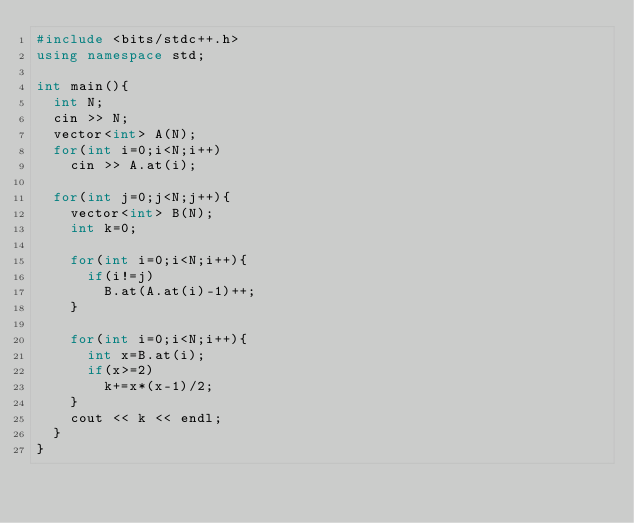<code> <loc_0><loc_0><loc_500><loc_500><_C++_>#include <bits/stdc++.h>
using namespace std;
 
int main(){
  int N;
  cin >> N;
  vector<int> A(N);
  for(int i=0;i<N;i++)
    cin >> A.at(i);
  
  for(int j=0;j<N;j++){
    vector<int> B(N);
    int k=0;
    
    for(int i=0;i<N;i++){
      if(i!=j)
        B.at(A.at(i)-1)++;
    }
    
    for(int i=0;i<N;i++){
      int x=B.at(i);
      if(x>=2)
        k+=x*(x-1)/2;
    }
    cout << k << endl;
  }
}</code> 